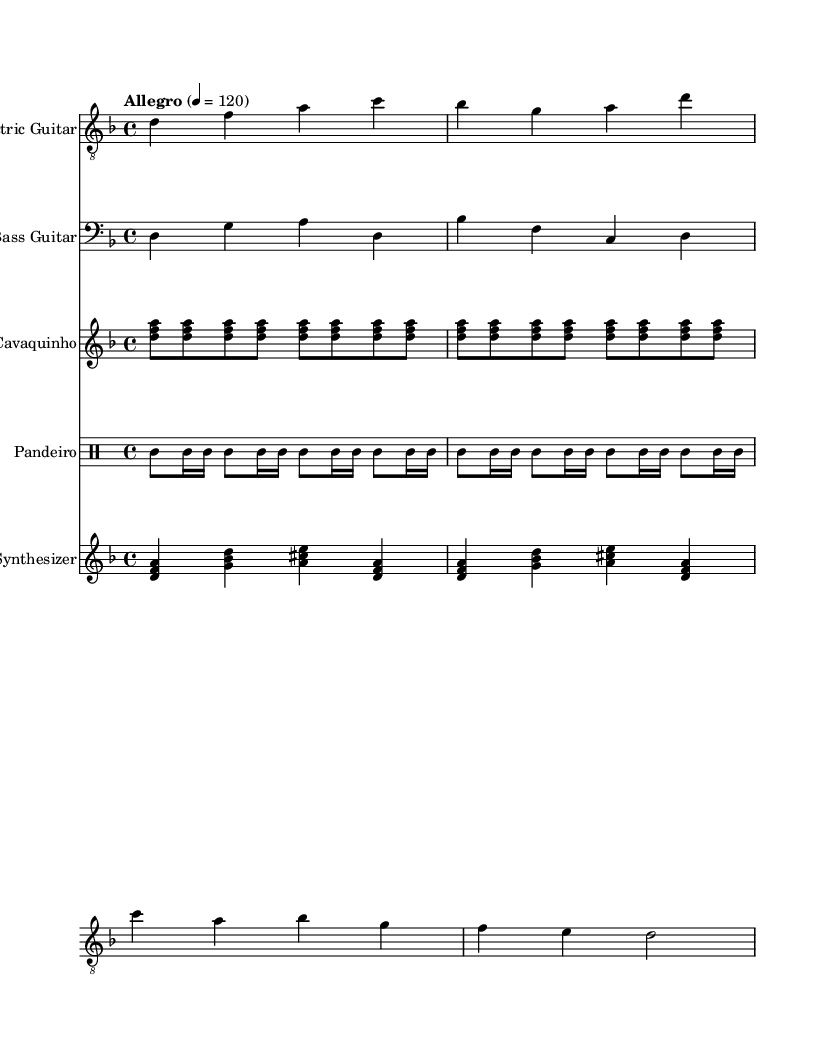What is the key signature of this music? The key signature is D minor, which is indicated at the beginning of the score with one flat (B flat).
Answer: D minor What is the time signature of the piece? The time signature is 4/4, as shown at the beginning of the score, indicating four beats per measure.
Answer: 4/4 What is the tempo marking for this piece? The tempo marking indicates "Allegro" with a speed of 120 beats per minute, which is specified at the start of the score.
Answer: Allegro 4 = 120 Which instruments are used in this composition? The score includes Electric Guitar, Bass Guitar, Cavaquinho, Pandeiro, and Synthesizer, shown in the respective staves.
Answer: Electric Guitar, Bass Guitar, Cavaquinho, Pandeiro, Synthesizer How many measures are there for the Electric Guitar part? The Electric Guitar part contains four measures as it is notated across four distinct bars in the staff.
Answer: 4 What rhythmic pattern is played by the Pandeiro? The Pandeiro part features a pattern of tambourine strikes indicated by "tamb" in both eight and sixteenth note durations.
Answer: tamb What unique element does this piece incorporate that relates to its World Music genre? The piece incorporates industrial sounds and rhythms with the synthesizer, blending traditional Brazilian sounds with modern elements.
Answer: Industrial sounds 